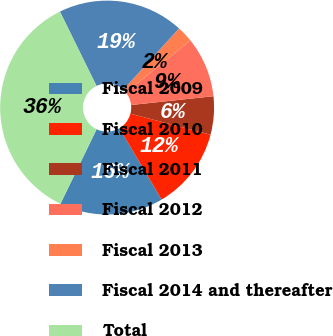Convert chart. <chart><loc_0><loc_0><loc_500><loc_500><pie_chart><fcel>Fiscal 2009<fcel>Fiscal 2010<fcel>Fiscal 2011<fcel>Fiscal 2012<fcel>Fiscal 2013<fcel>Fiscal 2014 and thereafter<fcel>Total<nl><fcel>15.7%<fcel>12.4%<fcel>5.78%<fcel>9.09%<fcel>2.48%<fcel>19.01%<fcel>35.54%<nl></chart> 